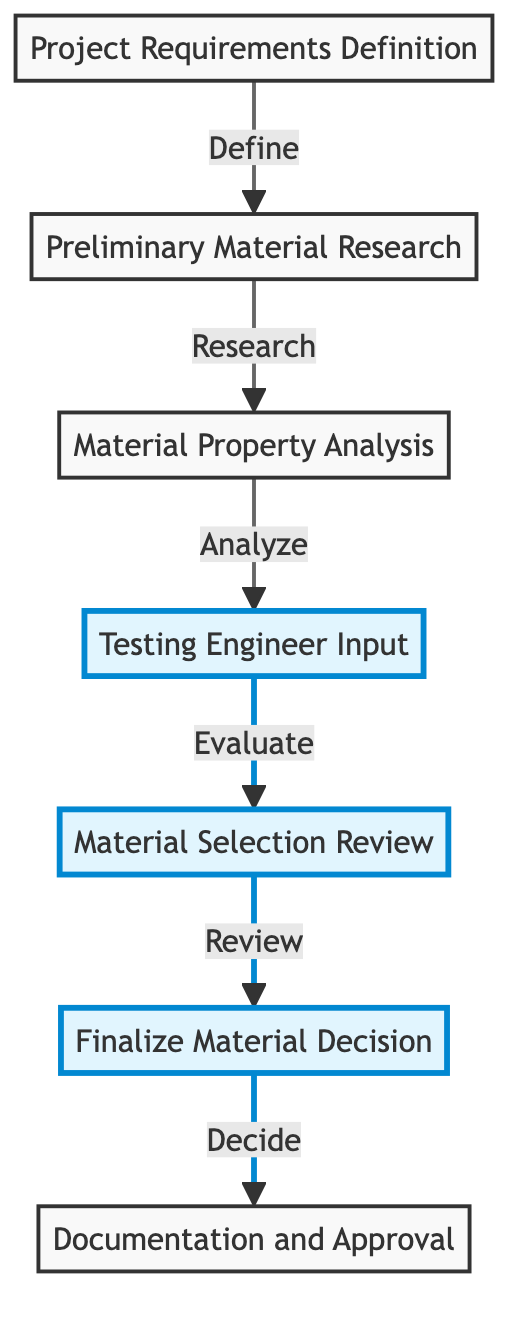What is the first node in the material selection process? The diagram clearly lists "Project Requirements Definition" as the starting point of the flow, which is the first step in the material selection process.
Answer: Project Requirements Definition How many nodes are present in the diagram? By counting all distinct process steps represented in the flow chart, we find that there are a total of seven nodes in the material selection process.
Answer: 7 What is the fourth step in the flow chart? Referring to the flow chart, the fourth step is labeled as "Testing Engineer Input," indicating the involvement of testing engineers in evaluating material performance.
Answer: Testing Engineer Input Which two nodes are highlighted in the diagram? The highlighted nodes that stand out due to their importance in the decision-making process are "Testing Engineer Input" and "Material Selection Review," indicating that they are crucial for material evaluation.
Answer: Testing Engineer Input, Material Selection Review What action follows the "Material Selection Review"? The flow chart shows that after the "Material Selection Review," the next action to be taken is to "Finalize Material Decision," indicating a progression towards making a selection based on the review findings.
Answer: Finalize Material Decision Which node results in documentation and approval? The final node in the flow chart leads to "Documentation and Approval," which signifies the importance of formally recording the selection process and obtaining necessary approvals.
Answer: Documentation and Approval How many connections (edges) are there in total? By counting the lines linking the nodes, we find that there are six edges in total that show the flow of the material selection process.
Answer: 6 What is the purpose of the "Material Property Analysis" step? According to the diagram, the "Material Property Analysis" step involves analyzing key properties of candidate materials, such as strength, durability, and cost, to inform the selection process.
Answer: Analyze key properties 